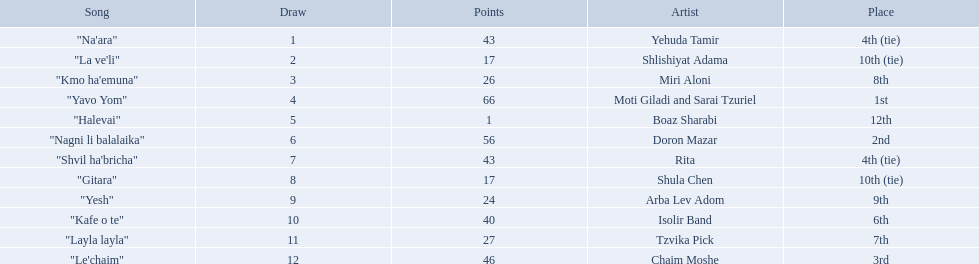Who are all of the artists? Yehuda Tamir, Shlishiyat Adama, Miri Aloni, Moti Giladi and Sarai Tzuriel, Boaz Sharabi, Doron Mazar, Rita, Shula Chen, Arba Lev Adom, Isolir Band, Tzvika Pick, Chaim Moshe. How many points did each score? 43, 17, 26, 66, 1, 56, 43, 17, 24, 40, 27, 46. And which artist had the least amount of points? Boaz Sharabi. How many artists are there? Yehuda Tamir, Shlishiyat Adama, Miri Aloni, Moti Giladi and Sarai Tzuriel, Boaz Sharabi, Doron Mazar, Rita, Shula Chen, Arba Lev Adom, Isolir Band, Tzvika Pick, Chaim Moshe. What is the least amount of points awarded? 1. Who was the artist awarded those points? Boaz Sharabi. 